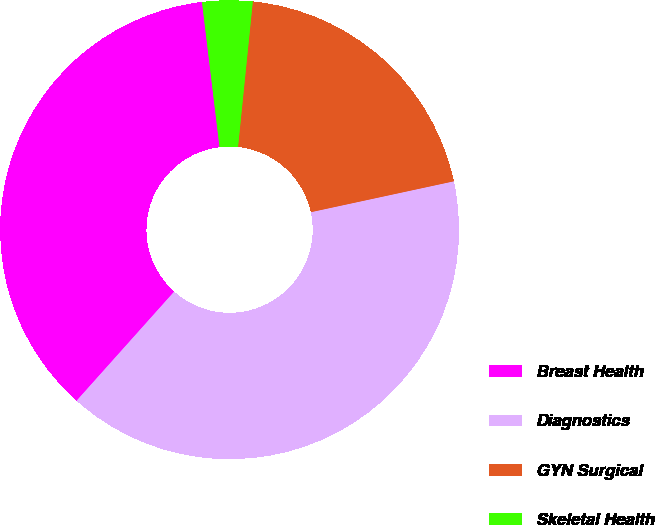Convert chart to OTSL. <chart><loc_0><loc_0><loc_500><loc_500><pie_chart><fcel>Breast Health<fcel>Diagnostics<fcel>GYN Surgical<fcel>Skeletal Health<nl><fcel>36.47%<fcel>40.0%<fcel>20.0%<fcel>3.53%<nl></chart> 